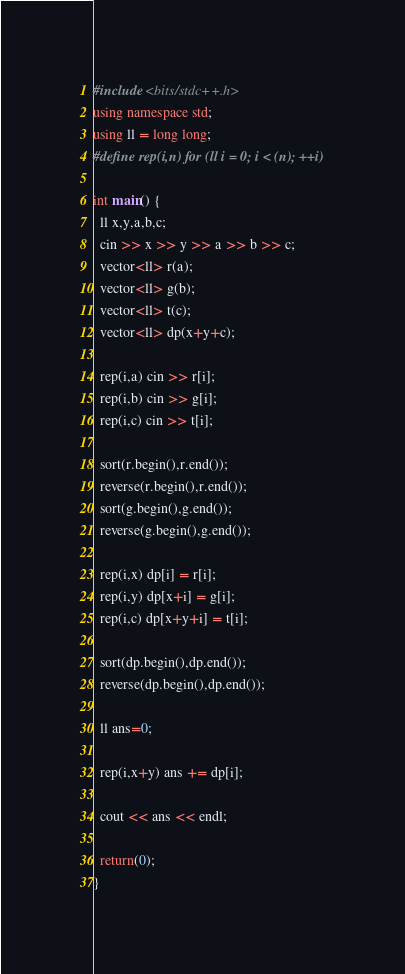<code> <loc_0><loc_0><loc_500><loc_500><_C++_>#include <bits/stdc++.h>
using namespace std;
using ll = long long;
#define rep(i,n) for (ll i = 0; i < (n); ++i)

int main() {
  ll x,y,a,b,c;
  cin >> x >> y >> a >> b >> c;
  vector<ll> r(a);
  vector<ll> g(b);
  vector<ll> t(c);
  vector<ll> dp(x+y+c);
  
  rep(i,a) cin >> r[i];
  rep(i,b) cin >> g[i];
  rep(i,c) cin >> t[i];
  
  sort(r.begin(),r.end());
  reverse(r.begin(),r.end());
  sort(g.begin(),g.end());
  reverse(g.begin(),g.end());
  
  rep(i,x) dp[i] = r[i];
  rep(i,y) dp[x+i] = g[i];
  rep(i,c) dp[x+y+i] = t[i];
  
  sort(dp.begin(),dp.end());
  reverse(dp.begin(),dp.end());
  
  ll ans=0;
  
  rep(i,x+y) ans += dp[i];
  
  cout << ans << endl;
  
  return(0);
}</code> 